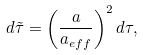Convert formula to latex. <formula><loc_0><loc_0><loc_500><loc_500>d \tilde { \tau } = \left ( \frac { a } { a _ { e f f } } \right ) ^ { 2 } d \tau ,</formula> 